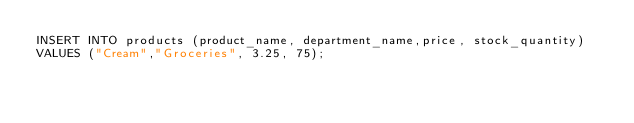<code> <loc_0><loc_0><loc_500><loc_500><_SQL_>INSERT INTO products (product_name, department_name,price, stock_quantity)
VALUES ("Cream","Groceries", 3.25, 75);</code> 